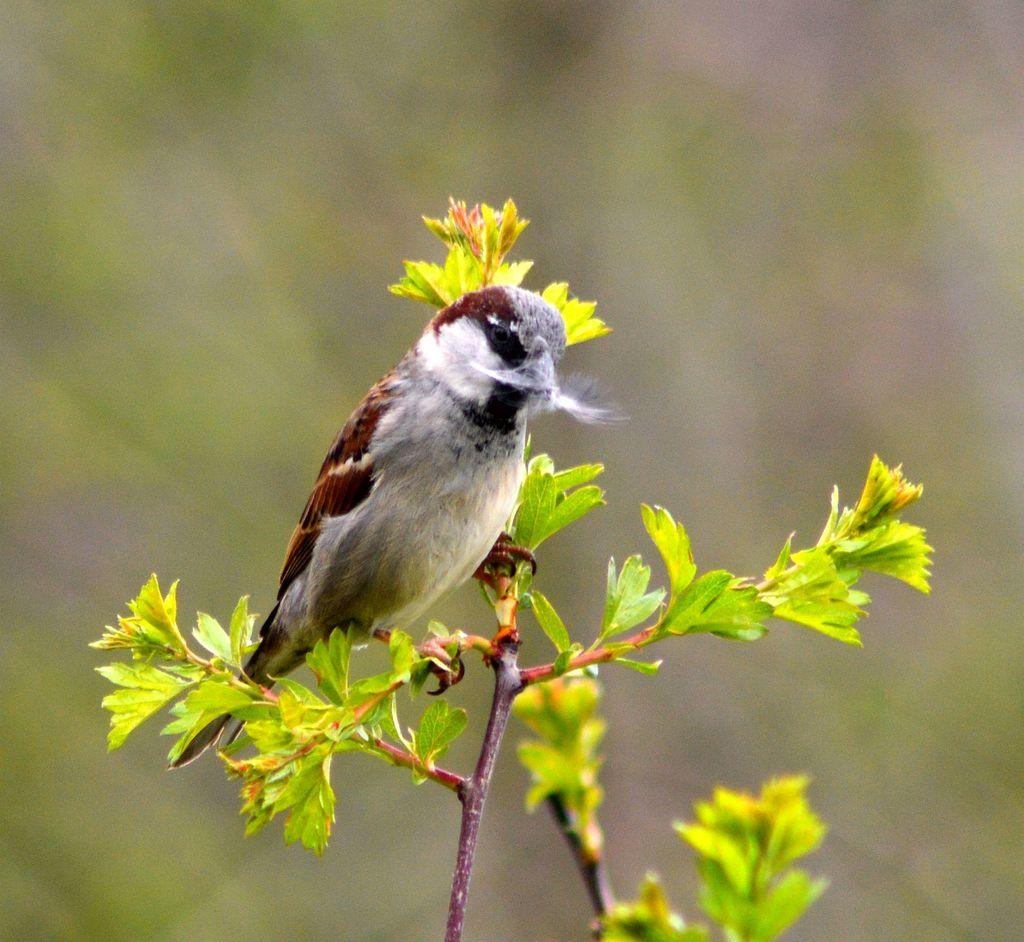What type of animal can be seen in the image? There is a bird in the image. Where is the bird located in the image? The bird is sitting on a plant. What type of smoke can be seen coming from the bird's beak in the image? There is no smoke visible coming from the bird's beak in the image. What does the bird have an interest in within the image? The facts provided do not mention any specific interests of the bird in the image. 